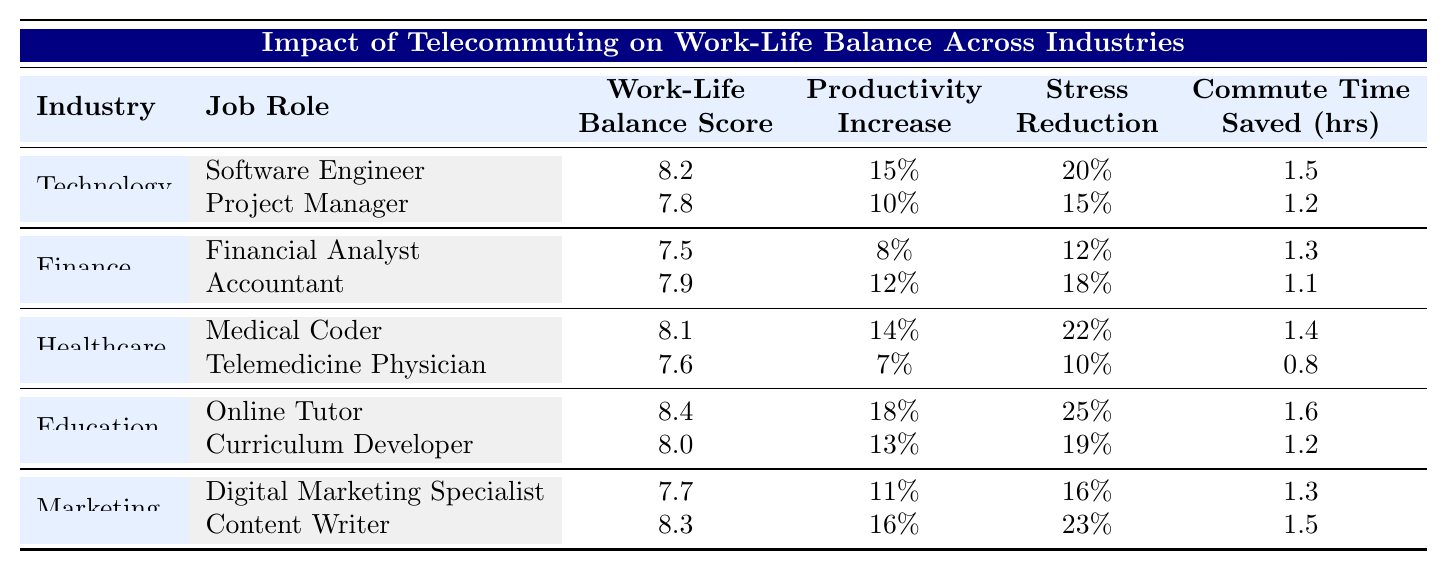What is the work-life balance score for the Online Tutor job role? The 'Online Tutor' job role is listed under the 'Education' industry, and the table shows its work-life balance score is 8.4.
Answer: 8.4 How much commute time is saved by the Software Engineer compared to the Telemedicine Physician? The 'Software Engineer' saves 1.5 hours, while the 'Telemedicine Physician' saves 0.8 hours. The difference is 1.5 - 0.8 = 0.7 hours.
Answer: 0.7 hours Which job role in the Finance industry has the highest work-life balance score? The 'Accountant' in the Finance industry has a work-life balance score of 7.9, which is higher than the 'Financial Analyst' score of 7.5.
Answer: Accountant Is the productivity increase for the Online Tutor higher than that of the Digital Marketing Specialist? The 'Online Tutor' has a productivity increase of 18%, whereas the 'Digital Marketing Specialist' has an increase of 11%. Since 18% > 11%, the statement is true.
Answer: Yes What is the average work-life balance score for all job roles in the Technology industry? The scores for the Technology job roles are 8.2 and 7.8. The average is (8.2 + 7.8) / 2 = 8.0.
Answer: 8.0 Which industry has the job role with the highest stress reduction percentage, and what is that percentage? In the 'Education' industry, the 'Online Tutor' has the highest stress reduction percentage of 25%, which is greater than any other job role.
Answer: Education, 25% Are there any job roles in the Healthcare industry that have a work-life balance score above 8? The 'Medical Coder' has a score of 8.1, which is above 8, and the 'Telemedicine Physician' has a score of 7.6, which does not. Therefore, there is one job role that meets the criterion.
Answer: Yes What is the total productivity increase percentage for job roles in the Marketing industry? The percentages for the Marketing roles are 11% (Digital Marketing Specialist) and 16% (Content Writer). The total is 11% + 16% = 27%.
Answer: 27% Which job role in the Healthcare industry has the lowest commute time saved, and how much is it? The 'Telemedicine Physician' saves 0.8 hours, which is less than the 1.4 hours saved by the 'Medical Coder'. Thus, it has the lowest commute time saved.
Answer: Telemedicine Physician, 0.8 hours What is the difference in work-life balance scores between the highest and lowest scoring job roles overall? The highest score is 8.4 (Online Tutor), and the lowest is 7.5 (Financial Analyst). The difference is 8.4 - 7.5 = 0.9.
Answer: 0.9 